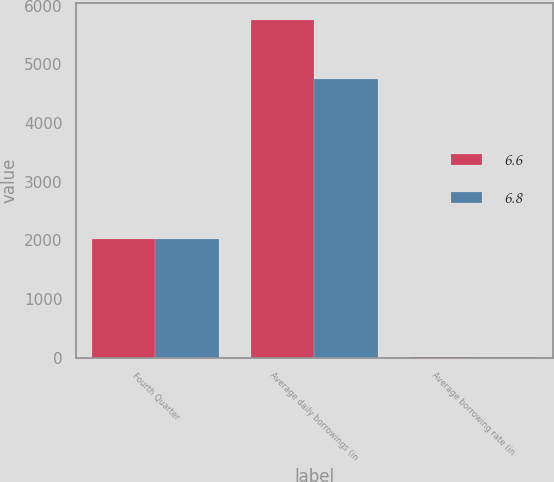Convert chart. <chart><loc_0><loc_0><loc_500><loc_500><stacked_bar_chart><ecel><fcel>Fourth Quarter<fcel>Average daily borrowings (in<fcel>Average borrowing rate (in<nl><fcel>6.6<fcel>2015<fcel>5756<fcel>6.8<nl><fcel>6.8<fcel>2014<fcel>4750<fcel>6.6<nl></chart> 